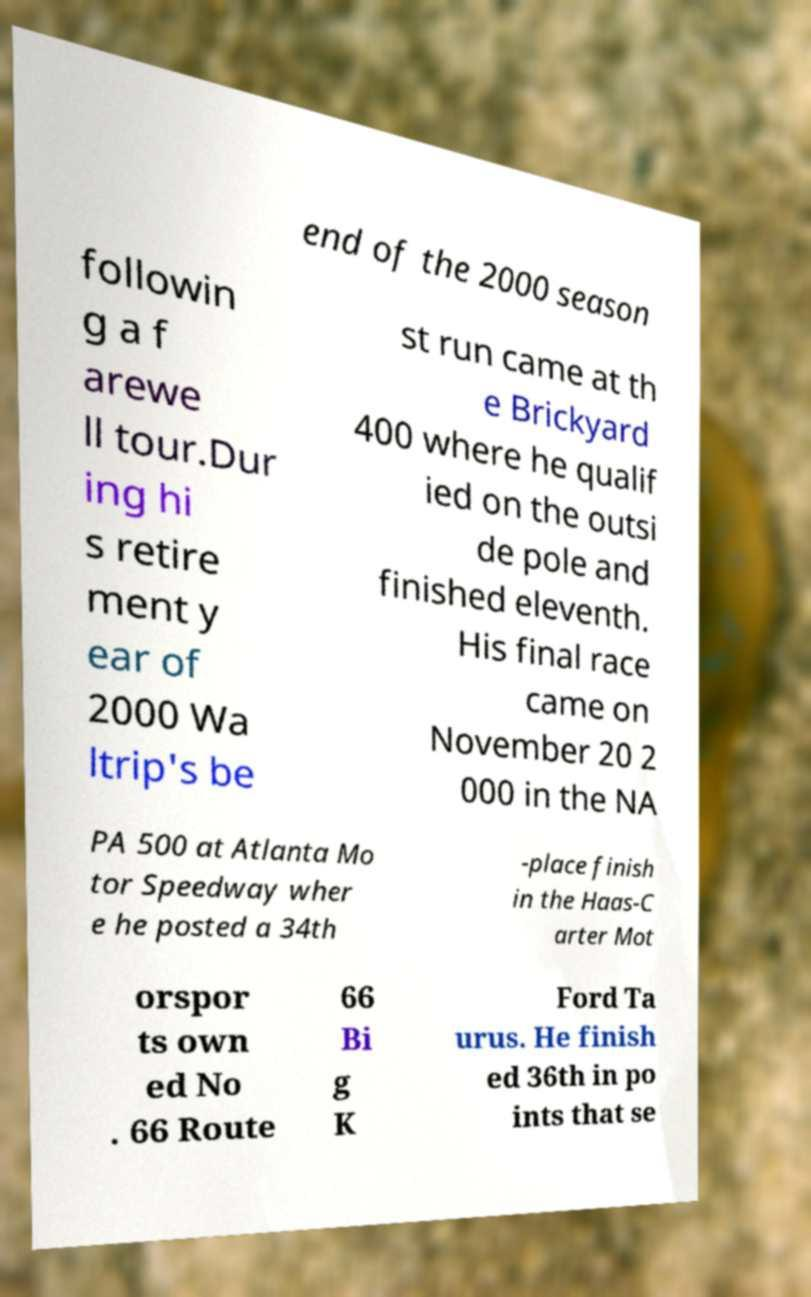For documentation purposes, I need the text within this image transcribed. Could you provide that? end of the 2000 season followin g a f arewe ll tour.Dur ing hi s retire ment y ear of 2000 Wa ltrip's be st run came at th e Brickyard 400 where he qualif ied on the outsi de pole and finished eleventh. His final race came on November 20 2 000 in the NA PA 500 at Atlanta Mo tor Speedway wher e he posted a 34th -place finish in the Haas-C arter Mot orspor ts own ed No . 66 Route 66 Bi g K Ford Ta urus. He finish ed 36th in po ints that se 